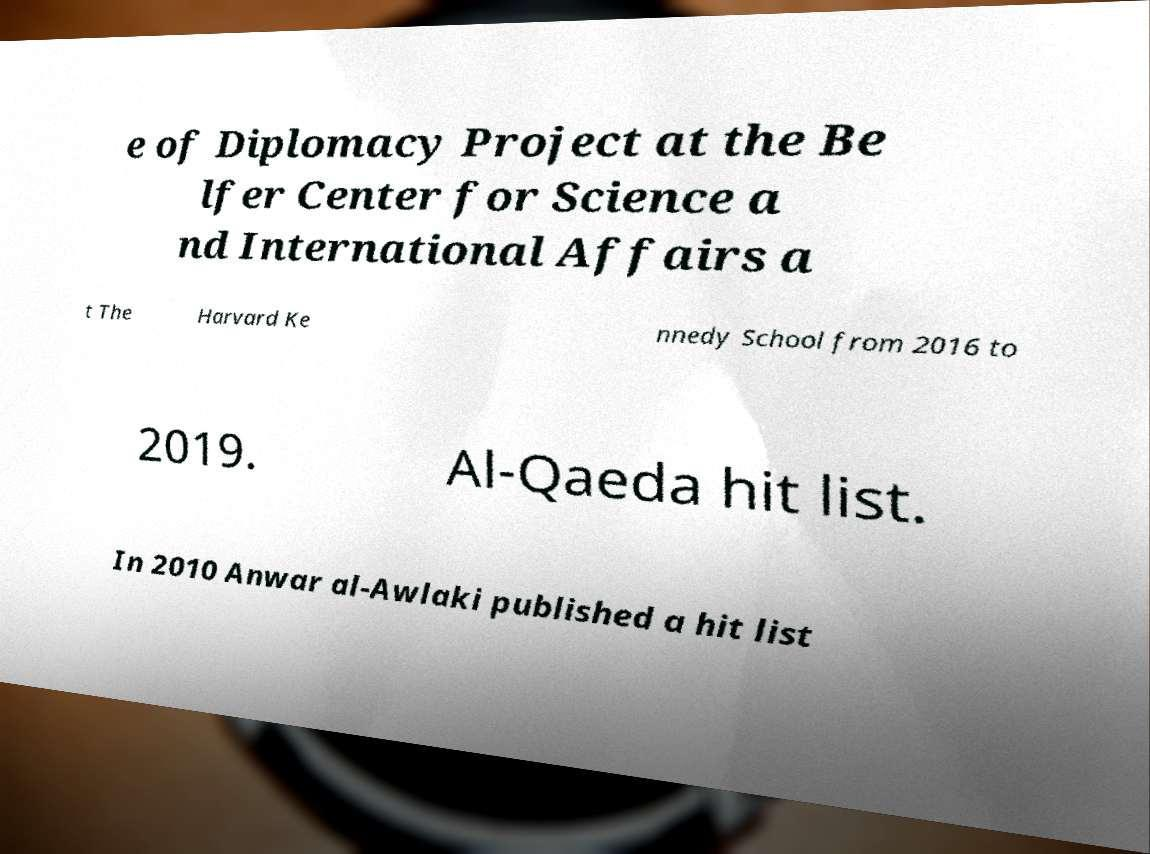Please identify and transcribe the text found in this image. e of Diplomacy Project at the Be lfer Center for Science a nd International Affairs a t The Harvard Ke nnedy School from 2016 to 2019. Al-Qaeda hit list. In 2010 Anwar al-Awlaki published a hit list 